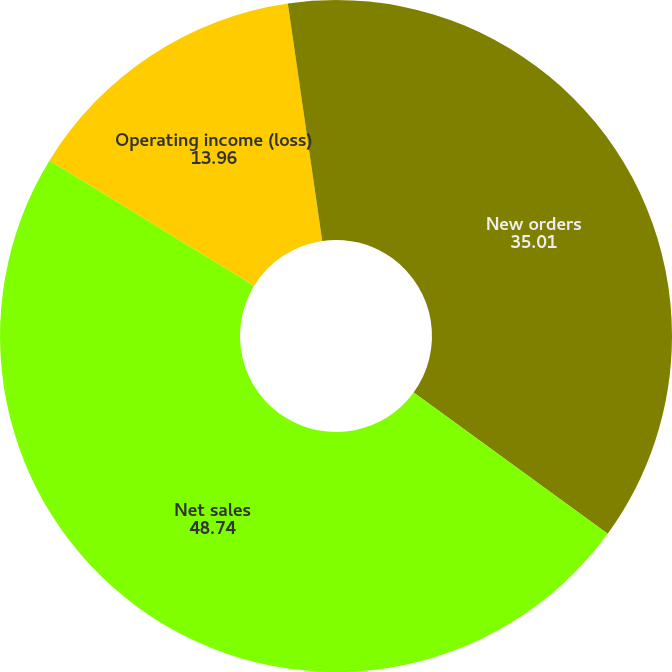Convert chart. <chart><loc_0><loc_0><loc_500><loc_500><pie_chart><fcel>New orders<fcel>Net sales<fcel>Operating income (loss)<fcel>Non-GAAP adjusted operating<nl><fcel>35.01%<fcel>48.74%<fcel>13.96%<fcel>2.29%<nl></chart> 